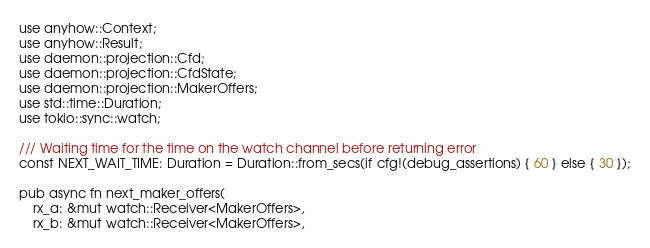Convert code to text. <code><loc_0><loc_0><loc_500><loc_500><_Rust_>use anyhow::Context;
use anyhow::Result;
use daemon::projection::Cfd;
use daemon::projection::CfdState;
use daemon::projection::MakerOffers;
use std::time::Duration;
use tokio::sync::watch;

/// Waiting time for the time on the watch channel before returning error
const NEXT_WAIT_TIME: Duration = Duration::from_secs(if cfg!(debug_assertions) { 60 } else { 30 });

pub async fn next_maker_offers(
    rx_a: &mut watch::Receiver<MakerOffers>,
    rx_b: &mut watch::Receiver<MakerOffers>,</code> 